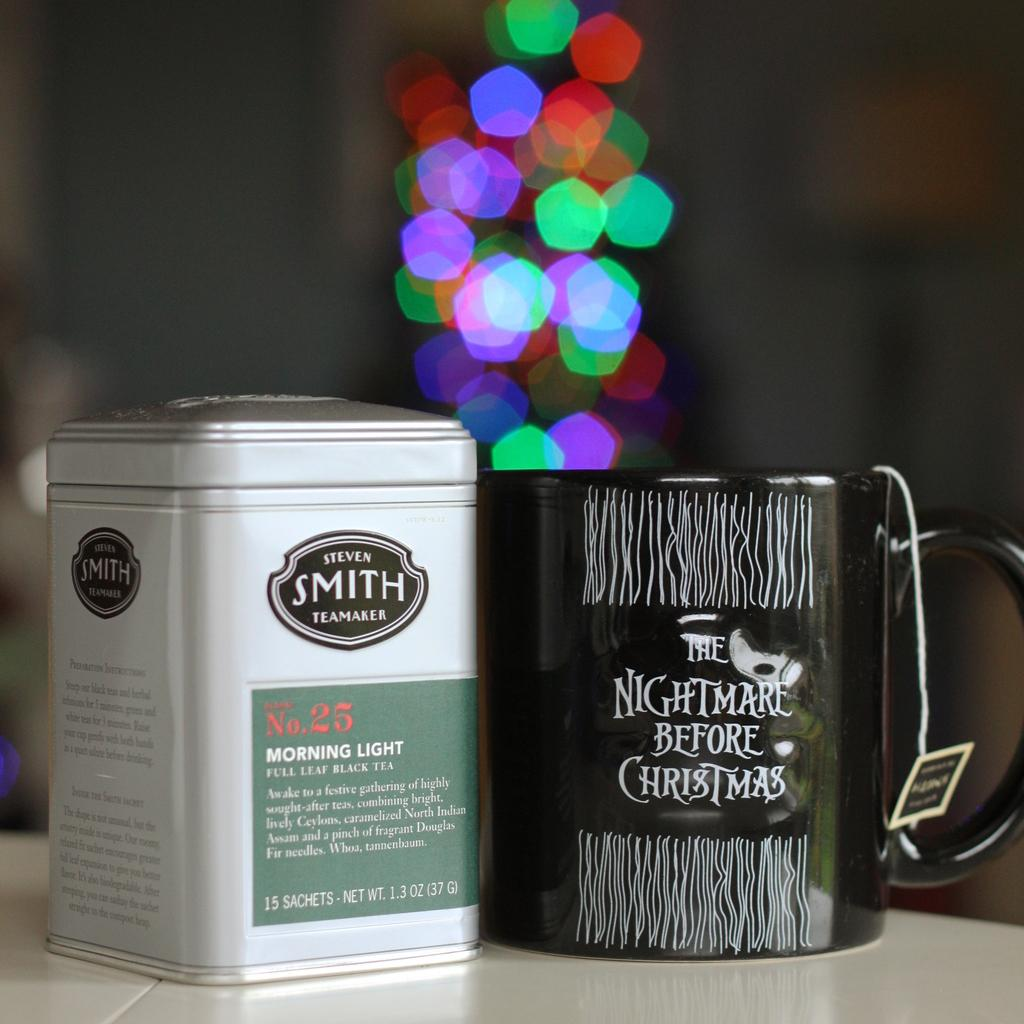What is one of the objects visible in the image? There is a cup in the image. What other object can be seen in the image? There is a box in the image. Where are the cup and the box located? Both the cup and the box are on a platform. Can you describe the background of the image? The background of the image is blurry. What type of air can be seen coming out of the cup in the image? There is no air coming out of the cup in the image. What kind of powder is visible inside the box in the image? There is no powder visible inside the box in the image. 